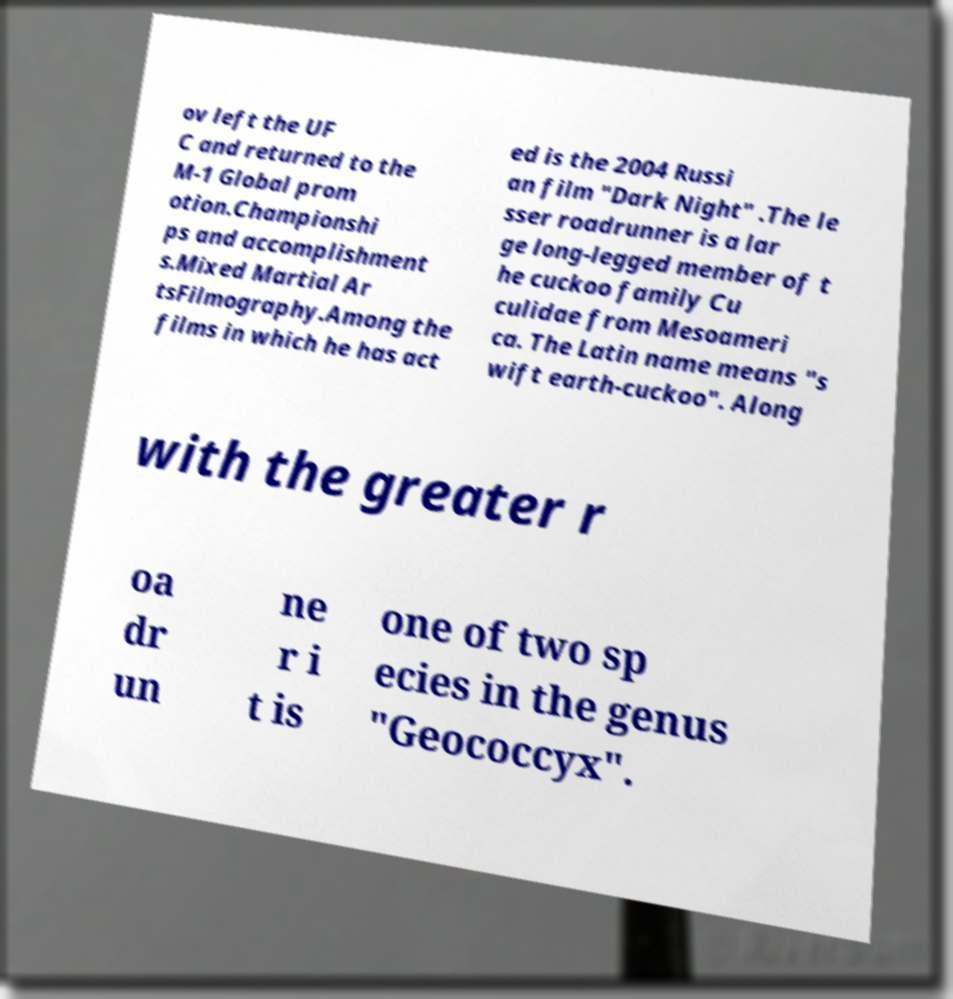Please identify and transcribe the text found in this image. ov left the UF C and returned to the M-1 Global prom otion.Championshi ps and accomplishment s.Mixed Martial Ar tsFilmography.Among the films in which he has act ed is the 2004 Russi an film "Dark Night" .The le sser roadrunner is a lar ge long-legged member of t he cuckoo family Cu culidae from Mesoameri ca. The Latin name means "s wift earth-cuckoo". Along with the greater r oa dr un ne r i t is one of two sp ecies in the genus "Geococcyx". 